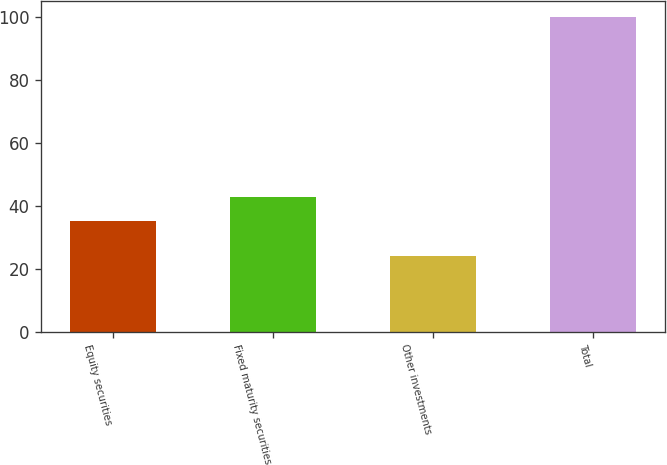Convert chart. <chart><loc_0><loc_0><loc_500><loc_500><bar_chart><fcel>Equity securities<fcel>Fixed maturity securities<fcel>Other investments<fcel>Total<nl><fcel>35<fcel>42.6<fcel>24<fcel>100<nl></chart> 